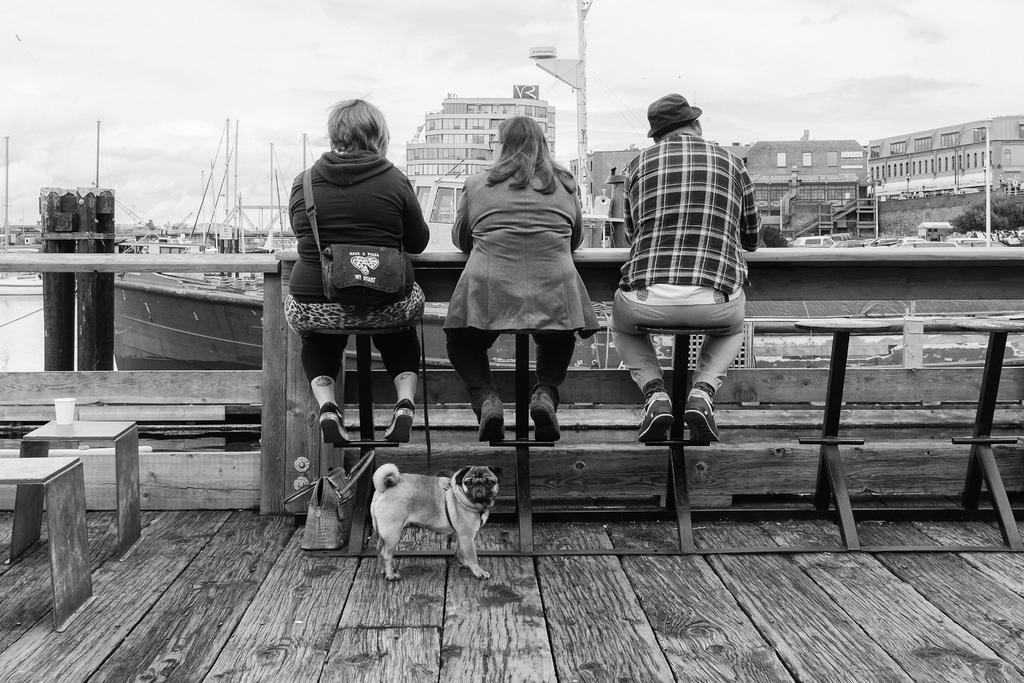Could you give a brief overview of what you see in this image? In this picture we can see a dog on a wooden surface, bags, glass, three people sitting on stools and in front of them we can see boats, trees, vehicles, poles, buildings with windows and some objects and in the background we can see the sky. 